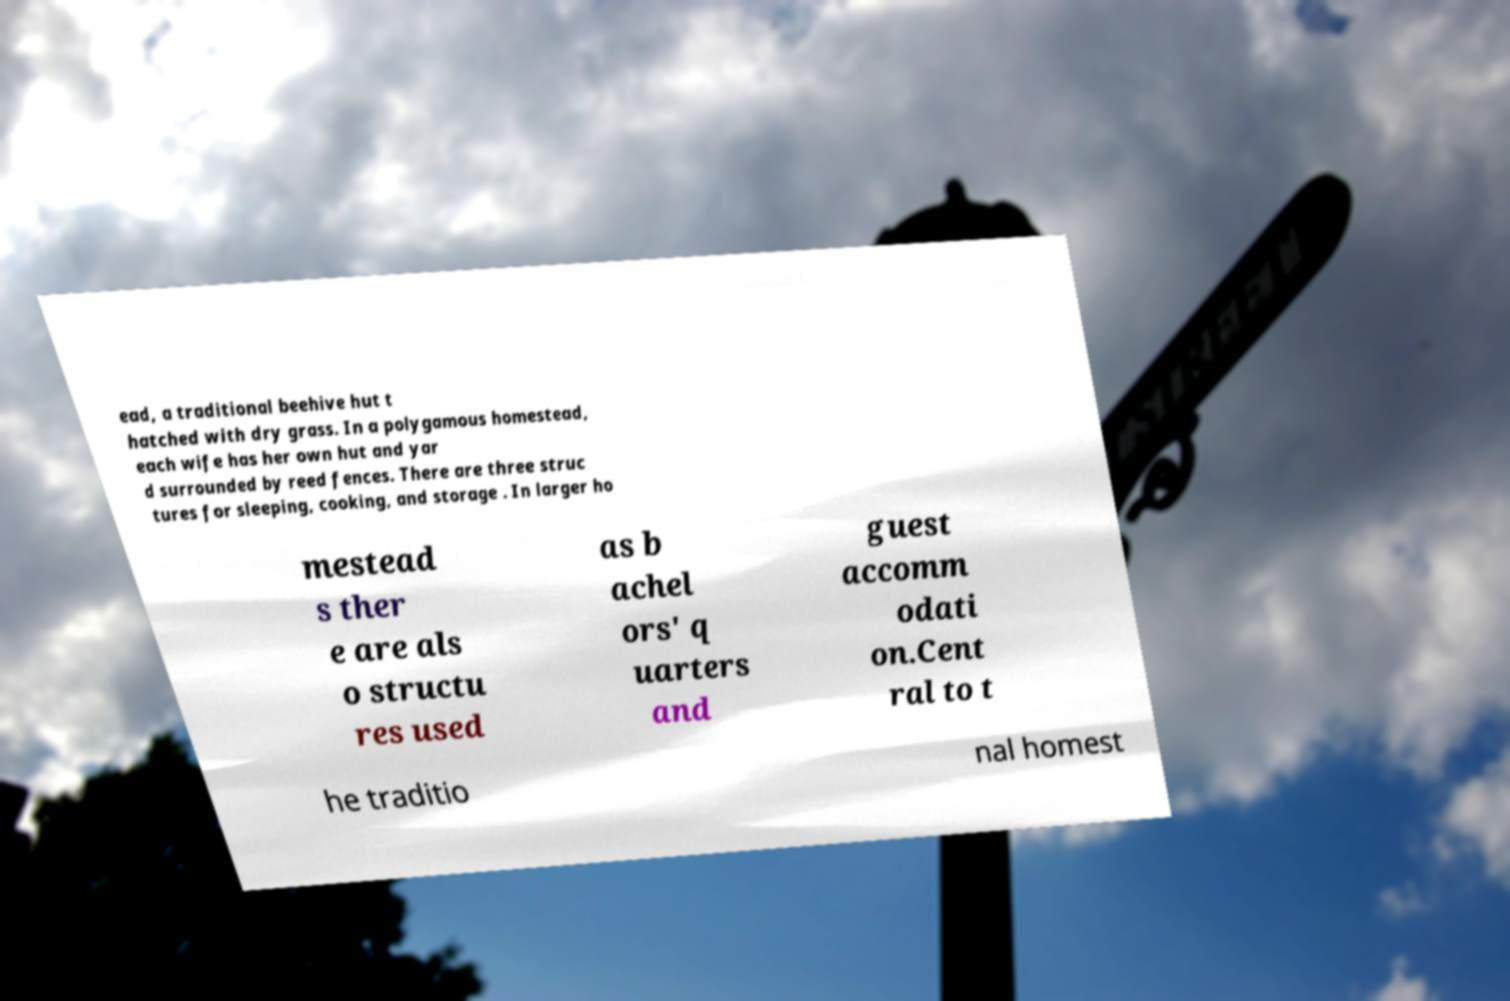Could you extract and type out the text from this image? ead, a traditional beehive hut t hatched with dry grass. In a polygamous homestead, each wife has her own hut and yar d surrounded by reed fences. There are three struc tures for sleeping, cooking, and storage . In larger ho mestead s ther e are als o structu res used as b achel ors' q uarters and guest accomm odati on.Cent ral to t he traditio nal homest 